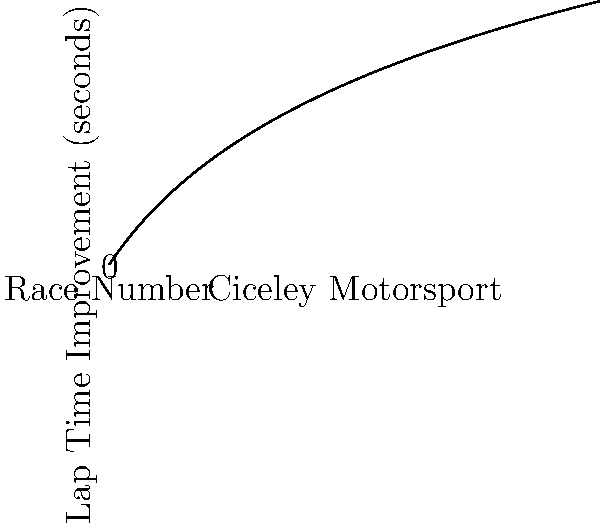The graph shows the lap time improvement of Ciceley Motorsport's lead driver over the course of several races. The improvement follows the function $f(x) = 2\ln(x+1)$, where $x$ is the race number and $f(x)$ is the improvement in seconds. After how many races will the driver's lap time improvement reach 3 seconds? To solve this problem, we need to follow these steps:

1) We're given the function $f(x) = 2\ln(x+1)$
2) We want to find $x$ when $f(x) = 3$

3) Let's set up the equation:
   $3 = 2\ln(x+1)$

4) Divide both sides by 2:
   $\frac{3}{2} = \ln(x+1)$

5) Apply $e$ to both sides to remove the natural log:
   $e^{\frac{3}{2}} = x+1$

6) Subtract 1 from both sides:
   $e^{\frac{3}{2}} - 1 = x$

7) Calculate this value:
   $x = e^{\frac{3}{2}} - 1 \approx 3.4816$

8) Since we're looking for a number of races, we need to round up to the next whole number.

Therefore, after 4 races, the driver's lap time improvement will reach 3 seconds.
Answer: 4 races 